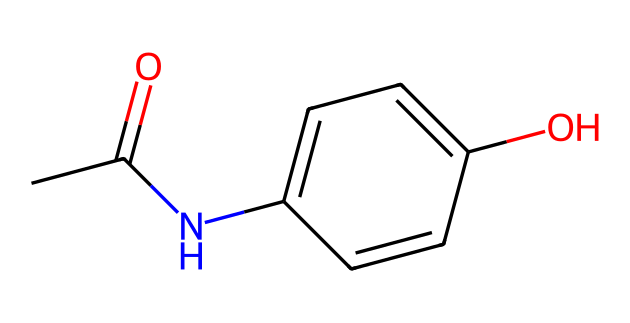What is the molecular formula of acetaminophen? The SMILES notation CC(=O)Nc1ccc(O)cc1 contains two carbon atoms in the acetate group (CC), one nitrogen atom (N), and a cyclic aromatic ring represented by c1ccc(O)cc1 which includes four more carbon atoms along with a hydroxyl group (O). Counting all the atoms, the formula can be derived as C8H9NO2.
Answer: C8H9NO2 How many carbon atoms are present in the acetaminophen structure? In the molecular structure represented by the SMILES, there are eight carbon atoms sourced from the acetate group (2) and the aromatic ring (6) which participates in resonance. By counting them, we confirm there are a total of 8 carbon atoms.
Answer: 8 What functional groups can be identified in acetaminophen? The SMILES notation indicates an amide group (CC(=O)N) and a hydroxyl group (O) on the aromatic ring. The amide is evident from the connection of the carbonyl (C=O) with nitrogen, while the hydroxyl group is attached directly to the aromatic ring.
Answer: amide and hydroxyl What type of chemical reaction would acetaminophen likely undergo when metabolized? Given its structure, acetaminophen, as a non-electrolyte, would typically undergo glucuronidation or sulfation reactions in the liver, whereby functional groups are modified to enhance solubility for excretion. This type of metabolic transformation modifies it, but it does not ionize in solution.
Answer: glucuronidation or sulfation How does the presence of the hydroxyl group influence the solubility of acetaminophen? The hydroxyl (-OH) group enhances polar character, increasing acetaminophen's solubility in water despite it being a non-electrolyte. The hydrogen bonding possible due to this hydroxyl group enables better interaction with water molecules.
Answer: increases solubility 